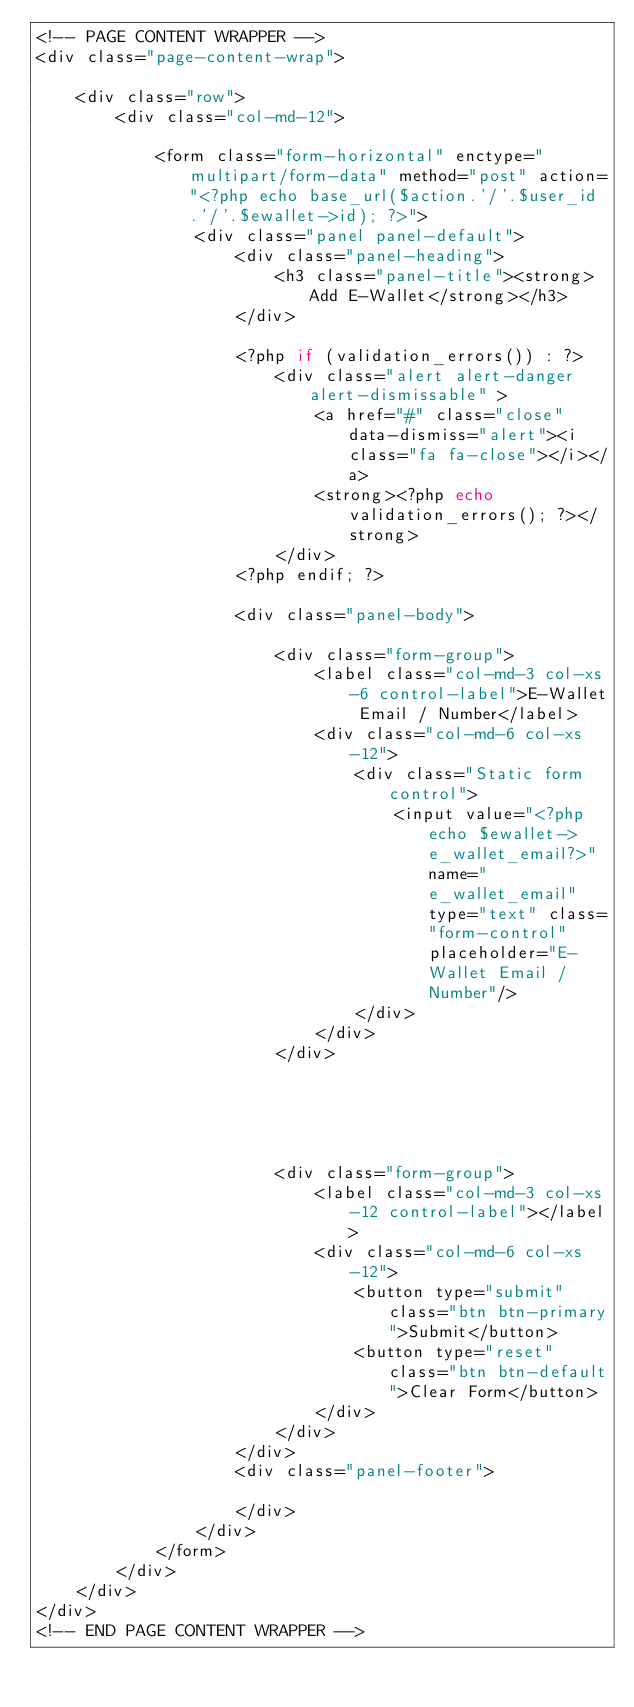Convert code to text. <code><loc_0><loc_0><loc_500><loc_500><_PHP_><!-- PAGE CONTENT WRAPPER -->
<div class="page-content-wrap">

    <div class="row">
        <div class="col-md-12">

            <form class="form-horizontal" enctype="multipart/form-data" method="post" action="<?php echo base_url($action.'/'.$user_id.'/'.$ewallet->id); ?>">
                <div class="panel panel-default">
                    <div class="panel-heading">
                        <h3 class="panel-title"><strong>Add E-Wallet</strong></h3>
                    </div>

                    <?php if (validation_errors()) : ?>
                        <div class="alert alert-danger alert-dismissable" >
                            <a href="#" class="close" data-dismiss="alert"><i class="fa fa-close"></i></a>
                            <strong><?php echo validation_errors(); ?></strong>
                        </div>
                    <?php endif; ?>

                    <div class="panel-body">

                        <div class="form-group">
                            <label class="col-md-3 col-xs-6 control-label">E-Wallet Email / Number</label>
                            <div class="col-md-6 col-xs-12">
                                <div class="Static form control">
                                    <input value="<?php echo $ewallet->e_wallet_email?>" name="e_wallet_email" type="text" class="form-control" placeholder="E-Wallet Email / Number"/>
                                </div>
                            </div>
                        </div>





                        <div class="form-group">
                            <label class="col-md-3 col-xs-12 control-label"></label>
                            <div class="col-md-6 col-xs-12">
                                <button type="submit" class="btn btn-primary">Submit</button>
                                <button type="reset" class="btn btn-default">Clear Form</button>
                            </div>
                        </div>
                    </div>
                    <div class="panel-footer">

                    </div>
                </div>
            </form>
        </div>
    </div>
</div>
<!-- END PAGE CONTENT WRAPPER -->
</code> 